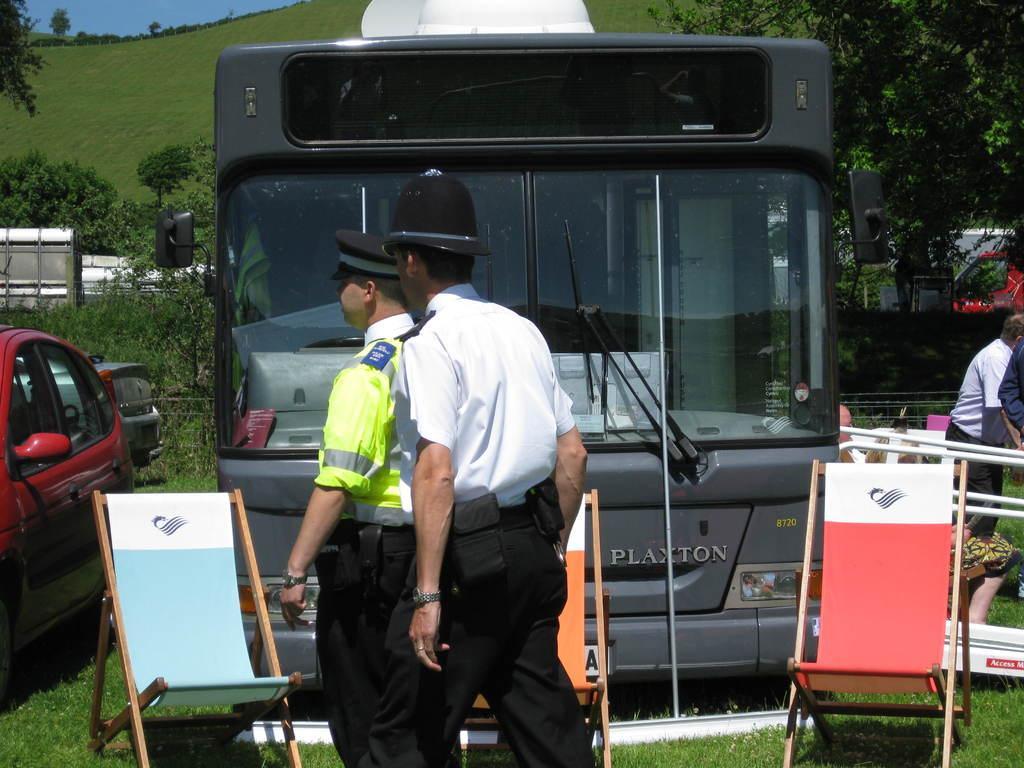Describe this image in one or two sentences. In the picture we can see two policemen are standing and near them, we can see three chairs, bus and a car and in the background, we can see the plants, trees and the hill covered with grass and on the top of it we can see the part of the sky. 